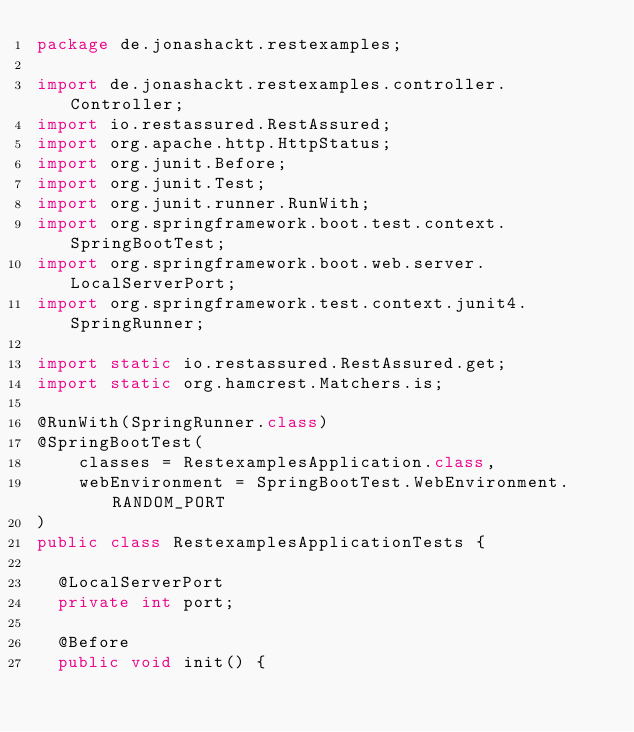<code> <loc_0><loc_0><loc_500><loc_500><_Java_>package de.jonashackt.restexamples;

import de.jonashackt.restexamples.controller.Controller;
import io.restassured.RestAssured;
import org.apache.http.HttpStatus;
import org.junit.Before;
import org.junit.Test;
import org.junit.runner.RunWith;
import org.springframework.boot.test.context.SpringBootTest;
import org.springframework.boot.web.server.LocalServerPort;
import org.springframework.test.context.junit4.SpringRunner;

import static io.restassured.RestAssured.get;
import static org.hamcrest.Matchers.is;

@RunWith(SpringRunner.class)
@SpringBootTest(
		classes = RestexamplesApplication.class,
		webEnvironment = SpringBootTest.WebEnvironment.RANDOM_PORT
)
public class RestexamplesApplicationTests {

	@LocalServerPort
	private int port;

	@Before
	public void init() {</code> 